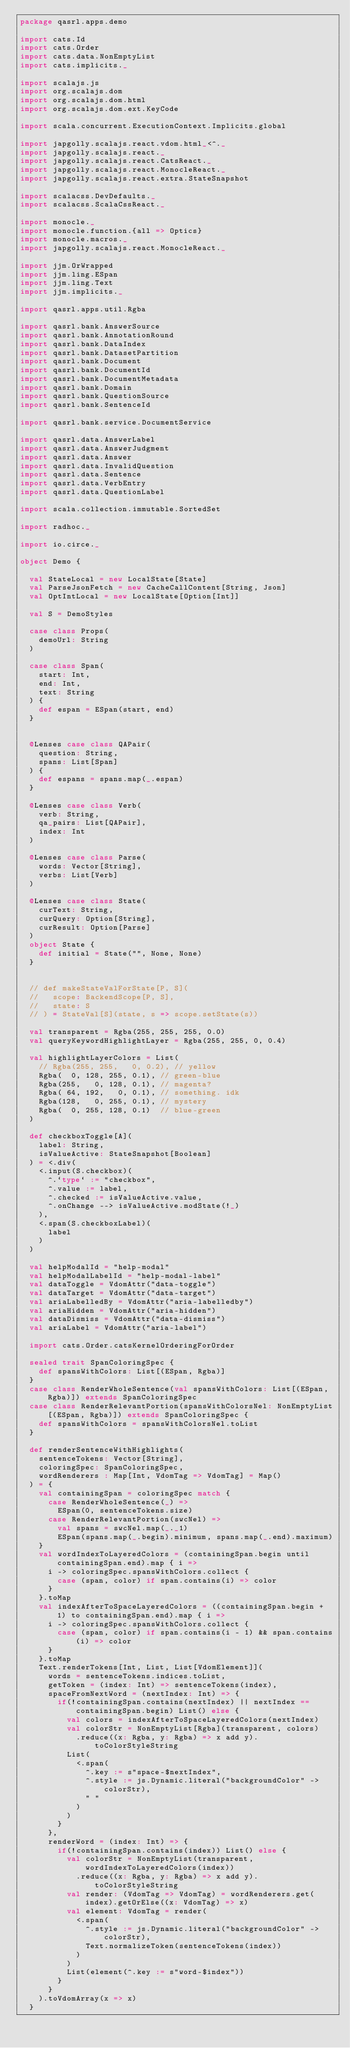Convert code to text. <code><loc_0><loc_0><loc_500><loc_500><_Scala_>package qasrl.apps.demo

import cats.Id
import cats.Order
import cats.data.NonEmptyList
import cats.implicits._

import scalajs.js
import org.scalajs.dom
import org.scalajs.dom.html
import org.scalajs.dom.ext.KeyCode

import scala.concurrent.ExecutionContext.Implicits.global

import japgolly.scalajs.react.vdom.html_<^._
import japgolly.scalajs.react._
import japgolly.scalajs.react.CatsReact._
import japgolly.scalajs.react.MonocleReact._
import japgolly.scalajs.react.extra.StateSnapshot

import scalacss.DevDefaults._
import scalacss.ScalaCssReact._

import monocle._
import monocle.function.{all => Optics}
import monocle.macros._
import japgolly.scalajs.react.MonocleReact._

import jjm.OrWrapped
import jjm.ling.ESpan
import jjm.ling.Text
import jjm.implicits._

import qasrl.apps.util.Rgba

import qasrl.bank.AnswerSource
import qasrl.bank.AnnotationRound
import qasrl.bank.DataIndex
import qasrl.bank.DatasetPartition
import qasrl.bank.Document
import qasrl.bank.DocumentId
import qasrl.bank.DocumentMetadata
import qasrl.bank.Domain
import qasrl.bank.QuestionSource
import qasrl.bank.SentenceId

import qasrl.bank.service.DocumentService

import qasrl.data.AnswerLabel
import qasrl.data.AnswerJudgment
import qasrl.data.Answer
import qasrl.data.InvalidQuestion
import qasrl.data.Sentence
import qasrl.data.VerbEntry
import qasrl.data.QuestionLabel

import scala.collection.immutable.SortedSet

import radhoc._

import io.circe._

object Demo {

  val StateLocal = new LocalState[State]
  val ParseJsonFetch = new CacheCallContent[String, Json]
  val OptIntLocal = new LocalState[Option[Int]]

  val S = DemoStyles

  case class Props(
    demoUrl: String
  )

  case class Span(
    start: Int,
    end: Int,
    text: String
  ) {
    def espan = ESpan(start, end)
  }


  @Lenses case class QAPair(
    question: String,
    spans: List[Span]
  ) {
    def espans = spans.map(_.espan)
  }

  @Lenses case class Verb(
    verb: String,
    qa_pairs: List[QAPair],
    index: Int
  )

  @Lenses case class Parse(
    words: Vector[String],
    verbs: List[Verb]
  )

  @Lenses case class State(
    curText: String,
    curQuery: Option[String],
    curResult: Option[Parse]
  )
  object State {
    def initial = State("", None, None)
  }


  // def makeStateValForState[P, S](
  //   scope: BackendScope[P, S],
  //   state: S
  // ) = StateVal[S](state, s => scope.setState(s))

  val transparent = Rgba(255, 255, 255, 0.0)
  val queryKeywordHighlightLayer = Rgba(255, 255, 0, 0.4)

  val highlightLayerColors = List(
    // Rgba(255, 255,   0, 0.2), // yellow
    Rgba(  0, 128, 255, 0.1), // green-blue
    Rgba(255,   0, 128, 0.1), // magenta?
    Rgba( 64, 192,   0, 0.1), // something. idk
    Rgba(128,   0, 255, 0.1), // mystery
    Rgba(  0, 255, 128, 0.1)  // blue-green
  )

  def checkboxToggle[A](
    label: String,
    isValueActive: StateSnapshot[Boolean]
  ) = <.div(
    <.input(S.checkbox)(
      ^.`type` := "checkbox",
      ^.value := label,
      ^.checked := isValueActive.value,
      ^.onChange --> isValueActive.modState(!_)
    ),
    <.span(S.checkboxLabel)(
      label
    )
  )

  val helpModalId = "help-modal"
  val helpModalLabelId = "help-modal-label"
  val dataToggle = VdomAttr("data-toggle")
  val dataTarget = VdomAttr("data-target")
  val ariaLabelledBy = VdomAttr("aria-labelledby")
  val ariaHidden = VdomAttr("aria-hidden")
  val dataDismiss = VdomAttr("data-dismiss")
  val ariaLabel = VdomAttr("aria-label")

  import cats.Order.catsKernelOrderingForOrder

  sealed trait SpanColoringSpec {
    def spansWithColors: List[(ESpan, Rgba)]
  }
  case class RenderWholeSentence(val spansWithColors: List[(ESpan, Rgba)]) extends SpanColoringSpec
  case class RenderRelevantPortion(spansWithColorsNel: NonEmptyList[(ESpan, Rgba)]) extends SpanColoringSpec {
    def spansWithColors = spansWithColorsNel.toList
  }

  def renderSentenceWithHighlights(
    sentenceTokens: Vector[String],
    coloringSpec: SpanColoringSpec,
    wordRenderers : Map[Int, VdomTag => VdomTag] = Map()
  ) = {
    val containingSpan = coloringSpec match {
      case RenderWholeSentence(_) =>
        ESpan(0, sentenceTokens.size)
      case RenderRelevantPortion(swcNel) =>
        val spans = swcNel.map(_._1)
        ESpan(spans.map(_.begin).minimum, spans.map(_.end).maximum)
    }
    val wordIndexToLayeredColors = (containingSpan.begin until containingSpan.end).map { i =>
      i -> coloringSpec.spansWithColors.collect {
        case (span, color) if span.contains(i) => color
      }
    }.toMap
    val indexAfterToSpaceLayeredColors = ((containingSpan.begin + 1) to containingSpan.end).map { i =>
      i -> coloringSpec.spansWithColors.collect {
        case (span, color) if span.contains(i - 1) && span.contains(i) => color
      }
    }.toMap
    Text.renderTokens[Int, List, List[VdomElement]](
      words = sentenceTokens.indices.toList,
      getToken = (index: Int) => sentenceTokens(index),
      spaceFromNextWord = (nextIndex: Int) => {
        if(!containingSpan.contains(nextIndex) || nextIndex == containingSpan.begin) List() else {
          val colors = indexAfterToSpaceLayeredColors(nextIndex)
          val colorStr = NonEmptyList[Rgba](transparent, colors)
            .reduce((x: Rgba, y: Rgba) => x add y).toColorStyleString
          List(
            <.span(
              ^.key := s"space-$nextIndex",
              ^.style := js.Dynamic.literal("backgroundColor" -> colorStr),
              " "
            )
          )
        }
      },
      renderWord = (index: Int) => {
        if(!containingSpan.contains(index)) List() else {
          val colorStr = NonEmptyList(transparent, wordIndexToLayeredColors(index))
            .reduce((x: Rgba, y: Rgba) => x add y).toColorStyleString
          val render: (VdomTag => VdomTag) = wordRenderers.get(index).getOrElse((x: VdomTag) => x)
          val element: VdomTag = render(
            <.span(
              ^.style := js.Dynamic.literal("backgroundColor" -> colorStr),
              Text.normalizeToken(sentenceTokens(index))
            )
          )
          List(element(^.key := s"word-$index"))
        }
      }
    ).toVdomArray(x => x)
  }
</code> 